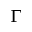<formula> <loc_0><loc_0><loc_500><loc_500>\Gamma</formula> 